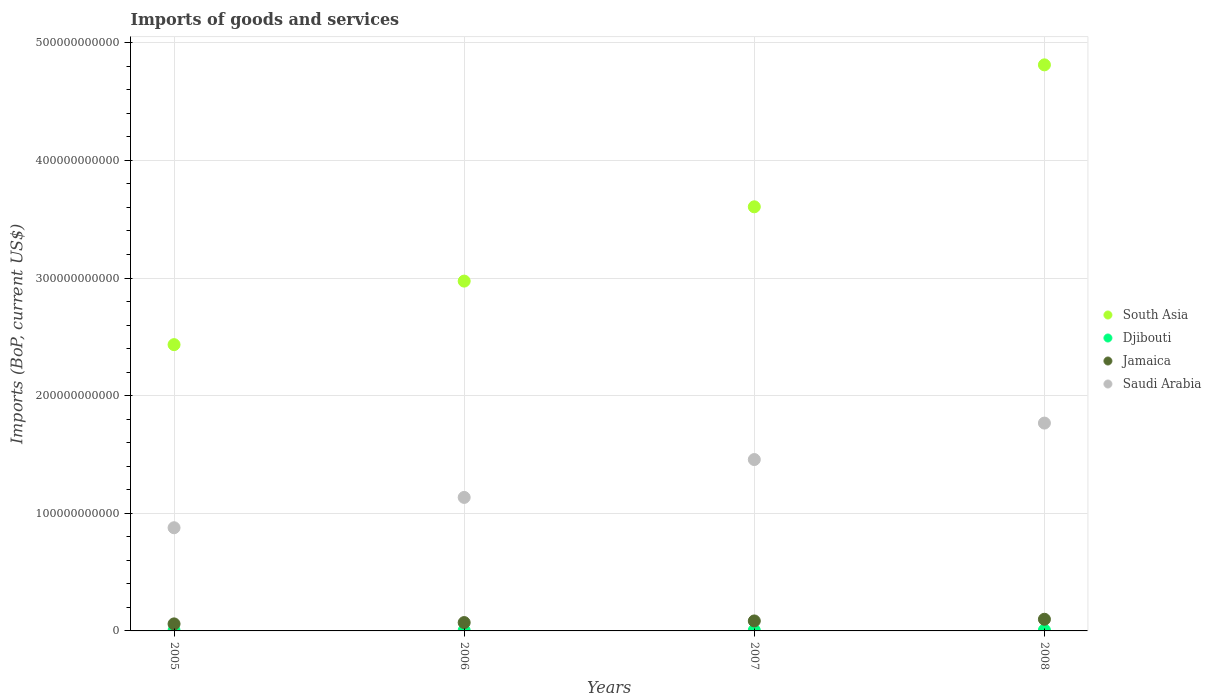How many different coloured dotlines are there?
Your response must be concise. 4. Is the number of dotlines equal to the number of legend labels?
Provide a short and direct response. Yes. What is the amount spent on imports in Djibouti in 2007?
Provide a short and direct response. 5.69e+08. Across all years, what is the maximum amount spent on imports in Jamaica?
Keep it short and to the point. 9.91e+09. Across all years, what is the minimum amount spent on imports in South Asia?
Provide a succinct answer. 2.43e+11. In which year was the amount spent on imports in Jamaica minimum?
Ensure brevity in your answer.  2005. What is the total amount spent on imports in Djibouti in the graph?
Your answer should be compact. 2.05e+09. What is the difference between the amount spent on imports in Saudi Arabia in 2006 and that in 2007?
Offer a terse response. -3.22e+1. What is the difference between the amount spent on imports in South Asia in 2006 and the amount spent on imports in Djibouti in 2008?
Provide a short and direct response. 2.97e+11. What is the average amount spent on imports in South Asia per year?
Your response must be concise. 3.46e+11. In the year 2005, what is the difference between the amount spent on imports in Saudi Arabia and amount spent on imports in Jamaica?
Give a very brief answer. 8.17e+1. In how many years, is the amount spent on imports in Saudi Arabia greater than 340000000000 US$?
Your answer should be very brief. 0. What is the ratio of the amount spent on imports in Djibouti in 2005 to that in 2007?
Ensure brevity in your answer.  0.64. Is the amount spent on imports in Jamaica in 2006 less than that in 2007?
Your response must be concise. Yes. Is the difference between the amount spent on imports in Saudi Arabia in 2005 and 2008 greater than the difference between the amount spent on imports in Jamaica in 2005 and 2008?
Ensure brevity in your answer.  No. What is the difference between the highest and the second highest amount spent on imports in Djibouti?
Offer a very short reply. 1.22e+08. What is the difference between the highest and the lowest amount spent on imports in Djibouti?
Your answer should be compact. 3.30e+08. In how many years, is the amount spent on imports in Djibouti greater than the average amount spent on imports in Djibouti taken over all years?
Your response must be concise. 2. Is it the case that in every year, the sum of the amount spent on imports in Djibouti and amount spent on imports in South Asia  is greater than the sum of amount spent on imports in Jamaica and amount spent on imports in Saudi Arabia?
Ensure brevity in your answer.  Yes. Is the amount spent on imports in Jamaica strictly less than the amount spent on imports in South Asia over the years?
Your answer should be compact. Yes. What is the difference between two consecutive major ticks on the Y-axis?
Make the answer very short. 1.00e+11. Does the graph contain any zero values?
Make the answer very short. No. Where does the legend appear in the graph?
Your answer should be compact. Center right. How many legend labels are there?
Provide a succinct answer. 4. How are the legend labels stacked?
Give a very brief answer. Vertical. What is the title of the graph?
Offer a terse response. Imports of goods and services. Does "Canada" appear as one of the legend labels in the graph?
Provide a succinct answer. No. What is the label or title of the Y-axis?
Give a very brief answer. Imports (BoP, current US$). What is the Imports (BoP, current US$) in South Asia in 2005?
Give a very brief answer. 2.43e+11. What is the Imports (BoP, current US$) of Djibouti in 2005?
Give a very brief answer. 3.61e+08. What is the Imports (BoP, current US$) of Jamaica in 2005?
Your answer should be very brief. 5.97e+09. What is the Imports (BoP, current US$) in Saudi Arabia in 2005?
Keep it short and to the point. 8.77e+1. What is the Imports (BoP, current US$) of South Asia in 2006?
Ensure brevity in your answer.  2.97e+11. What is the Imports (BoP, current US$) of Djibouti in 2006?
Give a very brief answer. 4.25e+08. What is the Imports (BoP, current US$) in Jamaica in 2006?
Ensure brevity in your answer.  7.10e+09. What is the Imports (BoP, current US$) of Saudi Arabia in 2006?
Provide a succinct answer. 1.13e+11. What is the Imports (BoP, current US$) of South Asia in 2007?
Ensure brevity in your answer.  3.61e+11. What is the Imports (BoP, current US$) of Djibouti in 2007?
Keep it short and to the point. 5.69e+08. What is the Imports (BoP, current US$) of Jamaica in 2007?
Your answer should be very brief. 8.49e+09. What is the Imports (BoP, current US$) of Saudi Arabia in 2007?
Offer a terse response. 1.46e+11. What is the Imports (BoP, current US$) in South Asia in 2008?
Your answer should be very brief. 4.81e+11. What is the Imports (BoP, current US$) of Djibouti in 2008?
Ensure brevity in your answer.  6.91e+08. What is the Imports (BoP, current US$) in Jamaica in 2008?
Give a very brief answer. 9.91e+09. What is the Imports (BoP, current US$) in Saudi Arabia in 2008?
Offer a terse response. 1.77e+11. Across all years, what is the maximum Imports (BoP, current US$) of South Asia?
Offer a terse response. 4.81e+11. Across all years, what is the maximum Imports (BoP, current US$) of Djibouti?
Offer a terse response. 6.91e+08. Across all years, what is the maximum Imports (BoP, current US$) of Jamaica?
Your answer should be very brief. 9.91e+09. Across all years, what is the maximum Imports (BoP, current US$) in Saudi Arabia?
Offer a very short reply. 1.77e+11. Across all years, what is the minimum Imports (BoP, current US$) of South Asia?
Offer a very short reply. 2.43e+11. Across all years, what is the minimum Imports (BoP, current US$) in Djibouti?
Provide a succinct answer. 3.61e+08. Across all years, what is the minimum Imports (BoP, current US$) in Jamaica?
Provide a succinct answer. 5.97e+09. Across all years, what is the minimum Imports (BoP, current US$) in Saudi Arabia?
Provide a short and direct response. 8.77e+1. What is the total Imports (BoP, current US$) of South Asia in the graph?
Your answer should be compact. 1.38e+12. What is the total Imports (BoP, current US$) of Djibouti in the graph?
Ensure brevity in your answer.  2.05e+09. What is the total Imports (BoP, current US$) in Jamaica in the graph?
Your response must be concise. 3.15e+1. What is the total Imports (BoP, current US$) in Saudi Arabia in the graph?
Your answer should be compact. 5.24e+11. What is the difference between the Imports (BoP, current US$) of South Asia in 2005 and that in 2006?
Keep it short and to the point. -5.40e+1. What is the difference between the Imports (BoP, current US$) in Djibouti in 2005 and that in 2006?
Offer a terse response. -6.39e+07. What is the difference between the Imports (BoP, current US$) of Jamaica in 2005 and that in 2006?
Give a very brief answer. -1.13e+09. What is the difference between the Imports (BoP, current US$) in Saudi Arabia in 2005 and that in 2006?
Make the answer very short. -2.58e+1. What is the difference between the Imports (BoP, current US$) of South Asia in 2005 and that in 2007?
Keep it short and to the point. -1.17e+11. What is the difference between the Imports (BoP, current US$) in Djibouti in 2005 and that in 2007?
Provide a succinct answer. -2.07e+08. What is the difference between the Imports (BoP, current US$) in Jamaica in 2005 and that in 2007?
Offer a terse response. -2.52e+09. What is the difference between the Imports (BoP, current US$) of Saudi Arabia in 2005 and that in 2007?
Offer a very short reply. -5.80e+1. What is the difference between the Imports (BoP, current US$) in South Asia in 2005 and that in 2008?
Make the answer very short. -2.38e+11. What is the difference between the Imports (BoP, current US$) of Djibouti in 2005 and that in 2008?
Keep it short and to the point. -3.30e+08. What is the difference between the Imports (BoP, current US$) of Jamaica in 2005 and that in 2008?
Give a very brief answer. -3.95e+09. What is the difference between the Imports (BoP, current US$) of Saudi Arabia in 2005 and that in 2008?
Keep it short and to the point. -8.90e+1. What is the difference between the Imports (BoP, current US$) in South Asia in 2006 and that in 2007?
Ensure brevity in your answer.  -6.32e+1. What is the difference between the Imports (BoP, current US$) of Djibouti in 2006 and that in 2007?
Provide a succinct answer. -1.44e+08. What is the difference between the Imports (BoP, current US$) in Jamaica in 2006 and that in 2007?
Ensure brevity in your answer.  -1.39e+09. What is the difference between the Imports (BoP, current US$) of Saudi Arabia in 2006 and that in 2007?
Your response must be concise. -3.22e+1. What is the difference between the Imports (BoP, current US$) of South Asia in 2006 and that in 2008?
Offer a terse response. -1.84e+11. What is the difference between the Imports (BoP, current US$) in Djibouti in 2006 and that in 2008?
Offer a very short reply. -2.66e+08. What is the difference between the Imports (BoP, current US$) of Jamaica in 2006 and that in 2008?
Your answer should be very brief. -2.82e+09. What is the difference between the Imports (BoP, current US$) in Saudi Arabia in 2006 and that in 2008?
Provide a succinct answer. -6.32e+1. What is the difference between the Imports (BoP, current US$) of South Asia in 2007 and that in 2008?
Make the answer very short. -1.21e+11. What is the difference between the Imports (BoP, current US$) of Djibouti in 2007 and that in 2008?
Keep it short and to the point. -1.22e+08. What is the difference between the Imports (BoP, current US$) of Jamaica in 2007 and that in 2008?
Offer a very short reply. -1.43e+09. What is the difference between the Imports (BoP, current US$) in Saudi Arabia in 2007 and that in 2008?
Your answer should be very brief. -3.10e+1. What is the difference between the Imports (BoP, current US$) of South Asia in 2005 and the Imports (BoP, current US$) of Djibouti in 2006?
Your answer should be compact. 2.43e+11. What is the difference between the Imports (BoP, current US$) of South Asia in 2005 and the Imports (BoP, current US$) of Jamaica in 2006?
Offer a very short reply. 2.36e+11. What is the difference between the Imports (BoP, current US$) in South Asia in 2005 and the Imports (BoP, current US$) in Saudi Arabia in 2006?
Provide a short and direct response. 1.30e+11. What is the difference between the Imports (BoP, current US$) in Djibouti in 2005 and the Imports (BoP, current US$) in Jamaica in 2006?
Ensure brevity in your answer.  -6.74e+09. What is the difference between the Imports (BoP, current US$) in Djibouti in 2005 and the Imports (BoP, current US$) in Saudi Arabia in 2006?
Provide a succinct answer. -1.13e+11. What is the difference between the Imports (BoP, current US$) in Jamaica in 2005 and the Imports (BoP, current US$) in Saudi Arabia in 2006?
Your response must be concise. -1.08e+11. What is the difference between the Imports (BoP, current US$) in South Asia in 2005 and the Imports (BoP, current US$) in Djibouti in 2007?
Your answer should be very brief. 2.43e+11. What is the difference between the Imports (BoP, current US$) in South Asia in 2005 and the Imports (BoP, current US$) in Jamaica in 2007?
Make the answer very short. 2.35e+11. What is the difference between the Imports (BoP, current US$) in South Asia in 2005 and the Imports (BoP, current US$) in Saudi Arabia in 2007?
Ensure brevity in your answer.  9.77e+1. What is the difference between the Imports (BoP, current US$) in Djibouti in 2005 and the Imports (BoP, current US$) in Jamaica in 2007?
Provide a succinct answer. -8.12e+09. What is the difference between the Imports (BoP, current US$) of Djibouti in 2005 and the Imports (BoP, current US$) of Saudi Arabia in 2007?
Provide a succinct answer. -1.45e+11. What is the difference between the Imports (BoP, current US$) in Jamaica in 2005 and the Imports (BoP, current US$) in Saudi Arabia in 2007?
Your answer should be compact. -1.40e+11. What is the difference between the Imports (BoP, current US$) in South Asia in 2005 and the Imports (BoP, current US$) in Djibouti in 2008?
Give a very brief answer. 2.43e+11. What is the difference between the Imports (BoP, current US$) of South Asia in 2005 and the Imports (BoP, current US$) of Jamaica in 2008?
Offer a very short reply. 2.33e+11. What is the difference between the Imports (BoP, current US$) of South Asia in 2005 and the Imports (BoP, current US$) of Saudi Arabia in 2008?
Your answer should be very brief. 6.67e+1. What is the difference between the Imports (BoP, current US$) in Djibouti in 2005 and the Imports (BoP, current US$) in Jamaica in 2008?
Offer a terse response. -9.55e+09. What is the difference between the Imports (BoP, current US$) in Djibouti in 2005 and the Imports (BoP, current US$) in Saudi Arabia in 2008?
Keep it short and to the point. -1.76e+11. What is the difference between the Imports (BoP, current US$) of Jamaica in 2005 and the Imports (BoP, current US$) of Saudi Arabia in 2008?
Your response must be concise. -1.71e+11. What is the difference between the Imports (BoP, current US$) of South Asia in 2006 and the Imports (BoP, current US$) of Djibouti in 2007?
Provide a succinct answer. 2.97e+11. What is the difference between the Imports (BoP, current US$) of South Asia in 2006 and the Imports (BoP, current US$) of Jamaica in 2007?
Provide a short and direct response. 2.89e+11. What is the difference between the Imports (BoP, current US$) of South Asia in 2006 and the Imports (BoP, current US$) of Saudi Arabia in 2007?
Make the answer very short. 1.52e+11. What is the difference between the Imports (BoP, current US$) in Djibouti in 2006 and the Imports (BoP, current US$) in Jamaica in 2007?
Provide a succinct answer. -8.06e+09. What is the difference between the Imports (BoP, current US$) in Djibouti in 2006 and the Imports (BoP, current US$) in Saudi Arabia in 2007?
Your answer should be very brief. -1.45e+11. What is the difference between the Imports (BoP, current US$) of Jamaica in 2006 and the Imports (BoP, current US$) of Saudi Arabia in 2007?
Your answer should be very brief. -1.39e+11. What is the difference between the Imports (BoP, current US$) of South Asia in 2006 and the Imports (BoP, current US$) of Djibouti in 2008?
Keep it short and to the point. 2.97e+11. What is the difference between the Imports (BoP, current US$) in South Asia in 2006 and the Imports (BoP, current US$) in Jamaica in 2008?
Give a very brief answer. 2.87e+11. What is the difference between the Imports (BoP, current US$) of South Asia in 2006 and the Imports (BoP, current US$) of Saudi Arabia in 2008?
Offer a very short reply. 1.21e+11. What is the difference between the Imports (BoP, current US$) in Djibouti in 2006 and the Imports (BoP, current US$) in Jamaica in 2008?
Your answer should be compact. -9.49e+09. What is the difference between the Imports (BoP, current US$) of Djibouti in 2006 and the Imports (BoP, current US$) of Saudi Arabia in 2008?
Offer a terse response. -1.76e+11. What is the difference between the Imports (BoP, current US$) of Jamaica in 2006 and the Imports (BoP, current US$) of Saudi Arabia in 2008?
Your answer should be compact. -1.70e+11. What is the difference between the Imports (BoP, current US$) of South Asia in 2007 and the Imports (BoP, current US$) of Djibouti in 2008?
Offer a very short reply. 3.60e+11. What is the difference between the Imports (BoP, current US$) in South Asia in 2007 and the Imports (BoP, current US$) in Jamaica in 2008?
Your response must be concise. 3.51e+11. What is the difference between the Imports (BoP, current US$) of South Asia in 2007 and the Imports (BoP, current US$) of Saudi Arabia in 2008?
Make the answer very short. 1.84e+11. What is the difference between the Imports (BoP, current US$) in Djibouti in 2007 and the Imports (BoP, current US$) in Jamaica in 2008?
Offer a very short reply. -9.35e+09. What is the difference between the Imports (BoP, current US$) in Djibouti in 2007 and the Imports (BoP, current US$) in Saudi Arabia in 2008?
Your answer should be very brief. -1.76e+11. What is the difference between the Imports (BoP, current US$) of Jamaica in 2007 and the Imports (BoP, current US$) of Saudi Arabia in 2008?
Make the answer very short. -1.68e+11. What is the average Imports (BoP, current US$) of South Asia per year?
Offer a very short reply. 3.46e+11. What is the average Imports (BoP, current US$) in Djibouti per year?
Your answer should be compact. 5.11e+08. What is the average Imports (BoP, current US$) of Jamaica per year?
Keep it short and to the point. 7.87e+09. What is the average Imports (BoP, current US$) of Saudi Arabia per year?
Offer a very short reply. 1.31e+11. In the year 2005, what is the difference between the Imports (BoP, current US$) in South Asia and Imports (BoP, current US$) in Djibouti?
Give a very brief answer. 2.43e+11. In the year 2005, what is the difference between the Imports (BoP, current US$) of South Asia and Imports (BoP, current US$) of Jamaica?
Your response must be concise. 2.37e+11. In the year 2005, what is the difference between the Imports (BoP, current US$) of South Asia and Imports (BoP, current US$) of Saudi Arabia?
Your answer should be very brief. 1.56e+11. In the year 2005, what is the difference between the Imports (BoP, current US$) in Djibouti and Imports (BoP, current US$) in Jamaica?
Offer a terse response. -5.61e+09. In the year 2005, what is the difference between the Imports (BoP, current US$) of Djibouti and Imports (BoP, current US$) of Saudi Arabia?
Your answer should be compact. -8.74e+1. In the year 2005, what is the difference between the Imports (BoP, current US$) in Jamaica and Imports (BoP, current US$) in Saudi Arabia?
Offer a terse response. -8.17e+1. In the year 2006, what is the difference between the Imports (BoP, current US$) of South Asia and Imports (BoP, current US$) of Djibouti?
Make the answer very short. 2.97e+11. In the year 2006, what is the difference between the Imports (BoP, current US$) of South Asia and Imports (BoP, current US$) of Jamaica?
Your answer should be very brief. 2.90e+11. In the year 2006, what is the difference between the Imports (BoP, current US$) of South Asia and Imports (BoP, current US$) of Saudi Arabia?
Your response must be concise. 1.84e+11. In the year 2006, what is the difference between the Imports (BoP, current US$) in Djibouti and Imports (BoP, current US$) in Jamaica?
Ensure brevity in your answer.  -6.67e+09. In the year 2006, what is the difference between the Imports (BoP, current US$) in Djibouti and Imports (BoP, current US$) in Saudi Arabia?
Make the answer very short. -1.13e+11. In the year 2006, what is the difference between the Imports (BoP, current US$) of Jamaica and Imports (BoP, current US$) of Saudi Arabia?
Offer a terse response. -1.06e+11. In the year 2007, what is the difference between the Imports (BoP, current US$) in South Asia and Imports (BoP, current US$) in Djibouti?
Your response must be concise. 3.60e+11. In the year 2007, what is the difference between the Imports (BoP, current US$) of South Asia and Imports (BoP, current US$) of Jamaica?
Make the answer very short. 3.52e+11. In the year 2007, what is the difference between the Imports (BoP, current US$) in South Asia and Imports (BoP, current US$) in Saudi Arabia?
Offer a very short reply. 2.15e+11. In the year 2007, what is the difference between the Imports (BoP, current US$) of Djibouti and Imports (BoP, current US$) of Jamaica?
Keep it short and to the point. -7.92e+09. In the year 2007, what is the difference between the Imports (BoP, current US$) of Djibouti and Imports (BoP, current US$) of Saudi Arabia?
Give a very brief answer. -1.45e+11. In the year 2007, what is the difference between the Imports (BoP, current US$) in Jamaica and Imports (BoP, current US$) in Saudi Arabia?
Your answer should be very brief. -1.37e+11. In the year 2008, what is the difference between the Imports (BoP, current US$) in South Asia and Imports (BoP, current US$) in Djibouti?
Offer a terse response. 4.81e+11. In the year 2008, what is the difference between the Imports (BoP, current US$) of South Asia and Imports (BoP, current US$) of Jamaica?
Keep it short and to the point. 4.71e+11. In the year 2008, what is the difference between the Imports (BoP, current US$) in South Asia and Imports (BoP, current US$) in Saudi Arabia?
Offer a very short reply. 3.05e+11. In the year 2008, what is the difference between the Imports (BoP, current US$) in Djibouti and Imports (BoP, current US$) in Jamaica?
Your answer should be compact. -9.22e+09. In the year 2008, what is the difference between the Imports (BoP, current US$) of Djibouti and Imports (BoP, current US$) of Saudi Arabia?
Provide a succinct answer. -1.76e+11. In the year 2008, what is the difference between the Imports (BoP, current US$) of Jamaica and Imports (BoP, current US$) of Saudi Arabia?
Your answer should be compact. -1.67e+11. What is the ratio of the Imports (BoP, current US$) in South Asia in 2005 to that in 2006?
Keep it short and to the point. 0.82. What is the ratio of the Imports (BoP, current US$) in Djibouti in 2005 to that in 2006?
Provide a short and direct response. 0.85. What is the ratio of the Imports (BoP, current US$) of Jamaica in 2005 to that in 2006?
Provide a short and direct response. 0.84. What is the ratio of the Imports (BoP, current US$) in Saudi Arabia in 2005 to that in 2006?
Ensure brevity in your answer.  0.77. What is the ratio of the Imports (BoP, current US$) of South Asia in 2005 to that in 2007?
Your answer should be very brief. 0.68. What is the ratio of the Imports (BoP, current US$) in Djibouti in 2005 to that in 2007?
Ensure brevity in your answer.  0.64. What is the ratio of the Imports (BoP, current US$) of Jamaica in 2005 to that in 2007?
Your answer should be compact. 0.7. What is the ratio of the Imports (BoP, current US$) of Saudi Arabia in 2005 to that in 2007?
Make the answer very short. 0.6. What is the ratio of the Imports (BoP, current US$) in South Asia in 2005 to that in 2008?
Offer a terse response. 0.51. What is the ratio of the Imports (BoP, current US$) of Djibouti in 2005 to that in 2008?
Offer a very short reply. 0.52. What is the ratio of the Imports (BoP, current US$) in Jamaica in 2005 to that in 2008?
Provide a short and direct response. 0.6. What is the ratio of the Imports (BoP, current US$) of Saudi Arabia in 2005 to that in 2008?
Offer a very short reply. 0.5. What is the ratio of the Imports (BoP, current US$) of South Asia in 2006 to that in 2007?
Keep it short and to the point. 0.82. What is the ratio of the Imports (BoP, current US$) in Djibouti in 2006 to that in 2007?
Provide a short and direct response. 0.75. What is the ratio of the Imports (BoP, current US$) in Jamaica in 2006 to that in 2007?
Ensure brevity in your answer.  0.84. What is the ratio of the Imports (BoP, current US$) of Saudi Arabia in 2006 to that in 2007?
Ensure brevity in your answer.  0.78. What is the ratio of the Imports (BoP, current US$) of South Asia in 2006 to that in 2008?
Offer a terse response. 0.62. What is the ratio of the Imports (BoP, current US$) in Djibouti in 2006 to that in 2008?
Provide a succinct answer. 0.62. What is the ratio of the Imports (BoP, current US$) of Jamaica in 2006 to that in 2008?
Your answer should be compact. 0.72. What is the ratio of the Imports (BoP, current US$) of Saudi Arabia in 2006 to that in 2008?
Your answer should be very brief. 0.64. What is the ratio of the Imports (BoP, current US$) of South Asia in 2007 to that in 2008?
Give a very brief answer. 0.75. What is the ratio of the Imports (BoP, current US$) of Djibouti in 2007 to that in 2008?
Provide a succinct answer. 0.82. What is the ratio of the Imports (BoP, current US$) of Jamaica in 2007 to that in 2008?
Ensure brevity in your answer.  0.86. What is the ratio of the Imports (BoP, current US$) of Saudi Arabia in 2007 to that in 2008?
Ensure brevity in your answer.  0.82. What is the difference between the highest and the second highest Imports (BoP, current US$) in South Asia?
Keep it short and to the point. 1.21e+11. What is the difference between the highest and the second highest Imports (BoP, current US$) of Djibouti?
Your response must be concise. 1.22e+08. What is the difference between the highest and the second highest Imports (BoP, current US$) in Jamaica?
Ensure brevity in your answer.  1.43e+09. What is the difference between the highest and the second highest Imports (BoP, current US$) of Saudi Arabia?
Provide a succinct answer. 3.10e+1. What is the difference between the highest and the lowest Imports (BoP, current US$) in South Asia?
Make the answer very short. 2.38e+11. What is the difference between the highest and the lowest Imports (BoP, current US$) in Djibouti?
Your answer should be compact. 3.30e+08. What is the difference between the highest and the lowest Imports (BoP, current US$) in Jamaica?
Your answer should be compact. 3.95e+09. What is the difference between the highest and the lowest Imports (BoP, current US$) in Saudi Arabia?
Provide a short and direct response. 8.90e+1. 